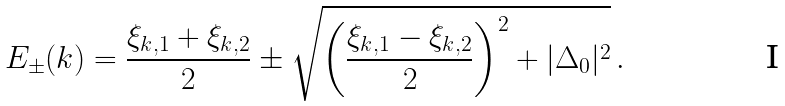Convert formula to latex. <formula><loc_0><loc_0><loc_500><loc_500>E _ { \pm } ( k ) = \frac { \xi _ { k , 1 } + \xi _ { k , 2 } } { 2 } \pm \sqrt { \left ( \frac { \xi _ { k , 1 } - \xi _ { k , 2 } } { 2 } \right ) ^ { 2 } + | \Delta _ { 0 } | ^ { 2 } } \, .</formula> 